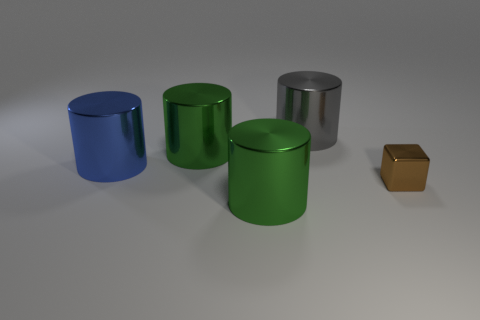Are there any other things that have the same size as the brown thing?
Your answer should be very brief. No. Are there more small metal things in front of the gray cylinder than brown objects?
Provide a succinct answer. No. There is a large thing that is in front of the thing to the right of the gray metallic cylinder; what is its color?
Your answer should be very brief. Green. What number of tiny brown metallic things are there?
Give a very brief answer. 1. How many things are both to the left of the gray metallic thing and behind the tiny brown thing?
Provide a short and direct response. 2. Is there anything else that has the same shape as the tiny brown metallic thing?
Give a very brief answer. No. There is a large green thing that is behind the cube; what is its shape?
Provide a succinct answer. Cylinder. What number of other things are there of the same material as the tiny cube
Give a very brief answer. 4. What material is the brown block?
Offer a very short reply. Metal. How many big objects are gray cylinders or shiny things?
Your answer should be compact. 4. 